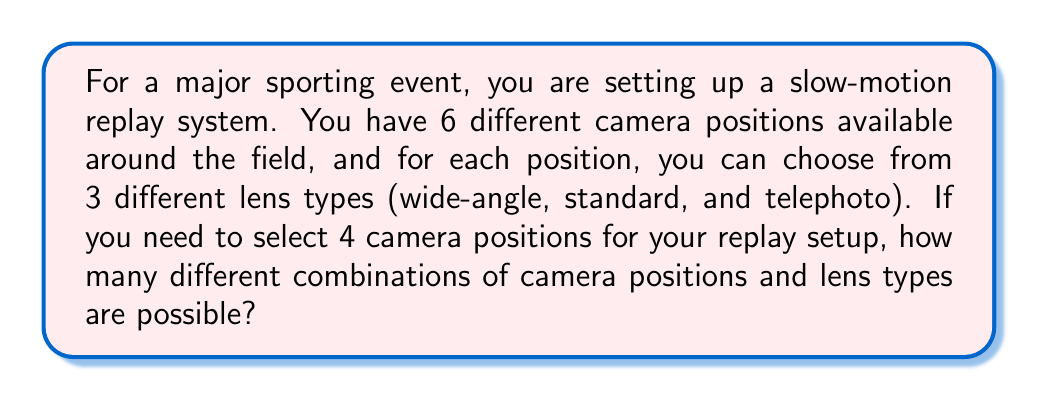Can you solve this math problem? Let's break this down step-by-step:

1) First, we need to choose 4 camera positions out of 6 available positions. This is a combination problem, represented as $\binom{6}{4}$ or $C(6,4)$.

   $\binom{6}{4} = \frac{6!}{4!(6-4)!} = \frac{6!}{4!2!} = 15$

2) For each of these 4 chosen positions, we need to select a lens type from 3 options. This is a case of independent choices for each position.

3) The number of ways to choose a lens for each position is 3, and we're doing this 4 times (once for each position). This scenario follows the multiplication principle.

4) Therefore, the total number of combinations is:

   $15 \cdot 3^4$

5) Let's calculate:
   $15 \cdot 3^4 = 15 \cdot 81 = 1,215$

Thus, there are 1,215 possible combinations of camera positions and lens types.
Answer: 1,215 